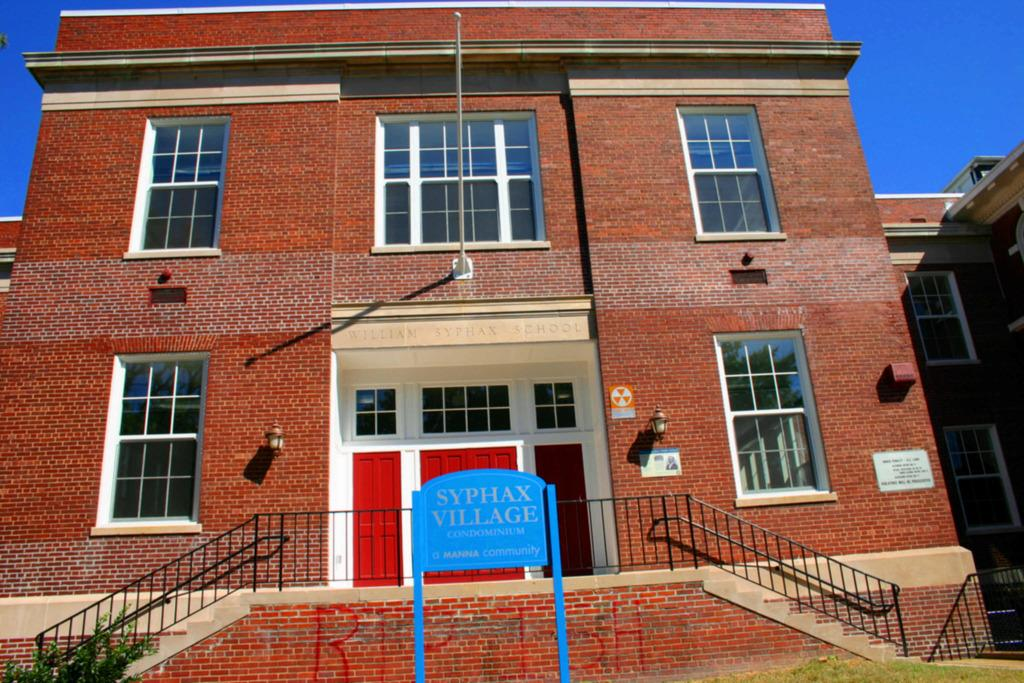What type of structure is visible in the image? There is a building in the image. What is located in front of the building? There is a plant and a board with text in front of the building. What can be seen in the background of the image? The sky is visible in the background of the image. How many eggs are in the eggnog being served in front of the building? There is no eggnog or eggs present in the image. 